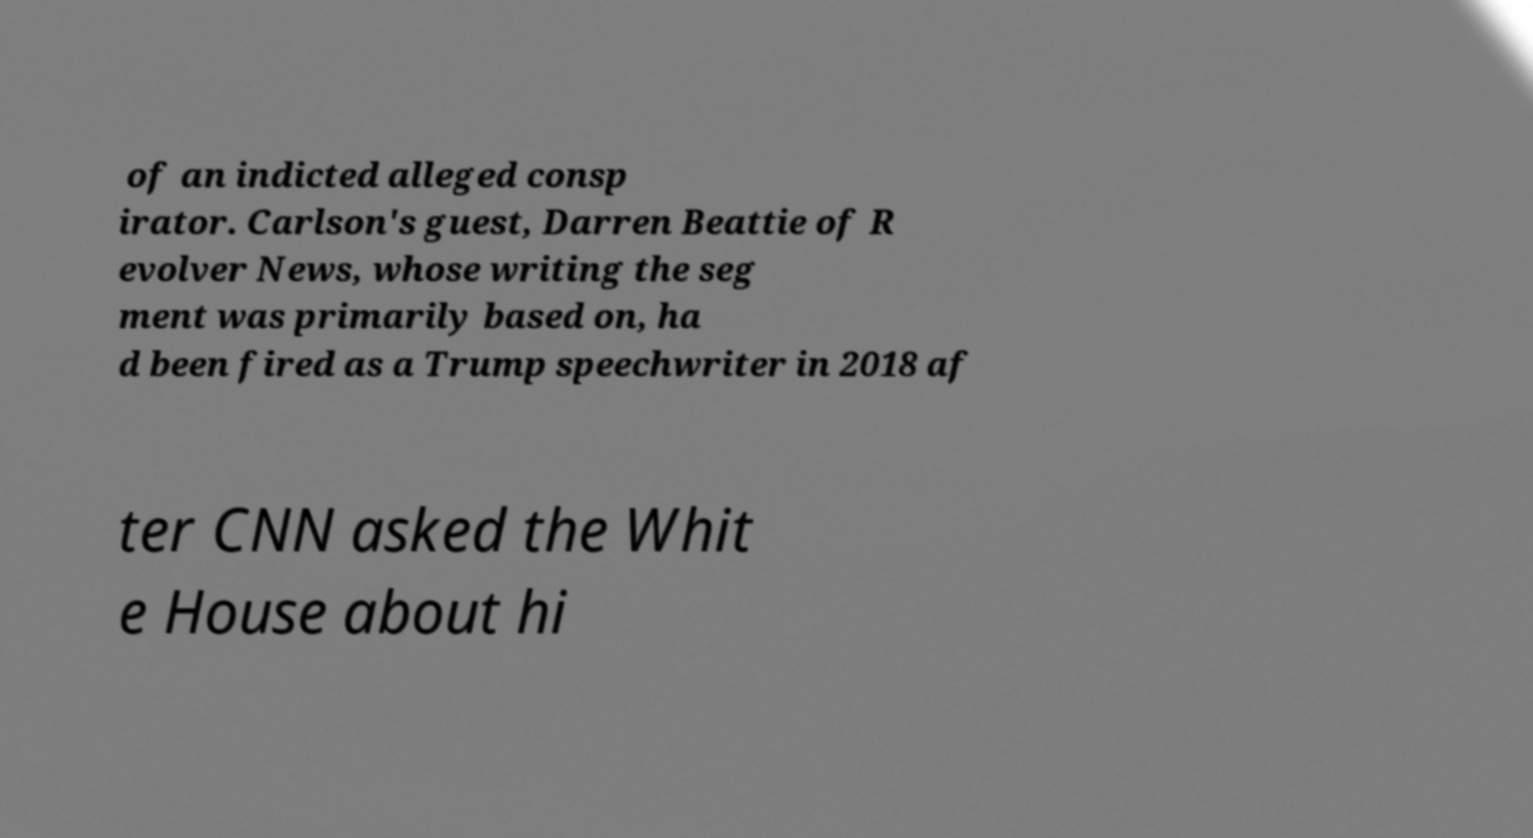What messages or text are displayed in this image? I need them in a readable, typed format. of an indicted alleged consp irator. Carlson's guest, Darren Beattie of R evolver News, whose writing the seg ment was primarily based on, ha d been fired as a Trump speechwriter in 2018 af ter CNN asked the Whit e House about hi 